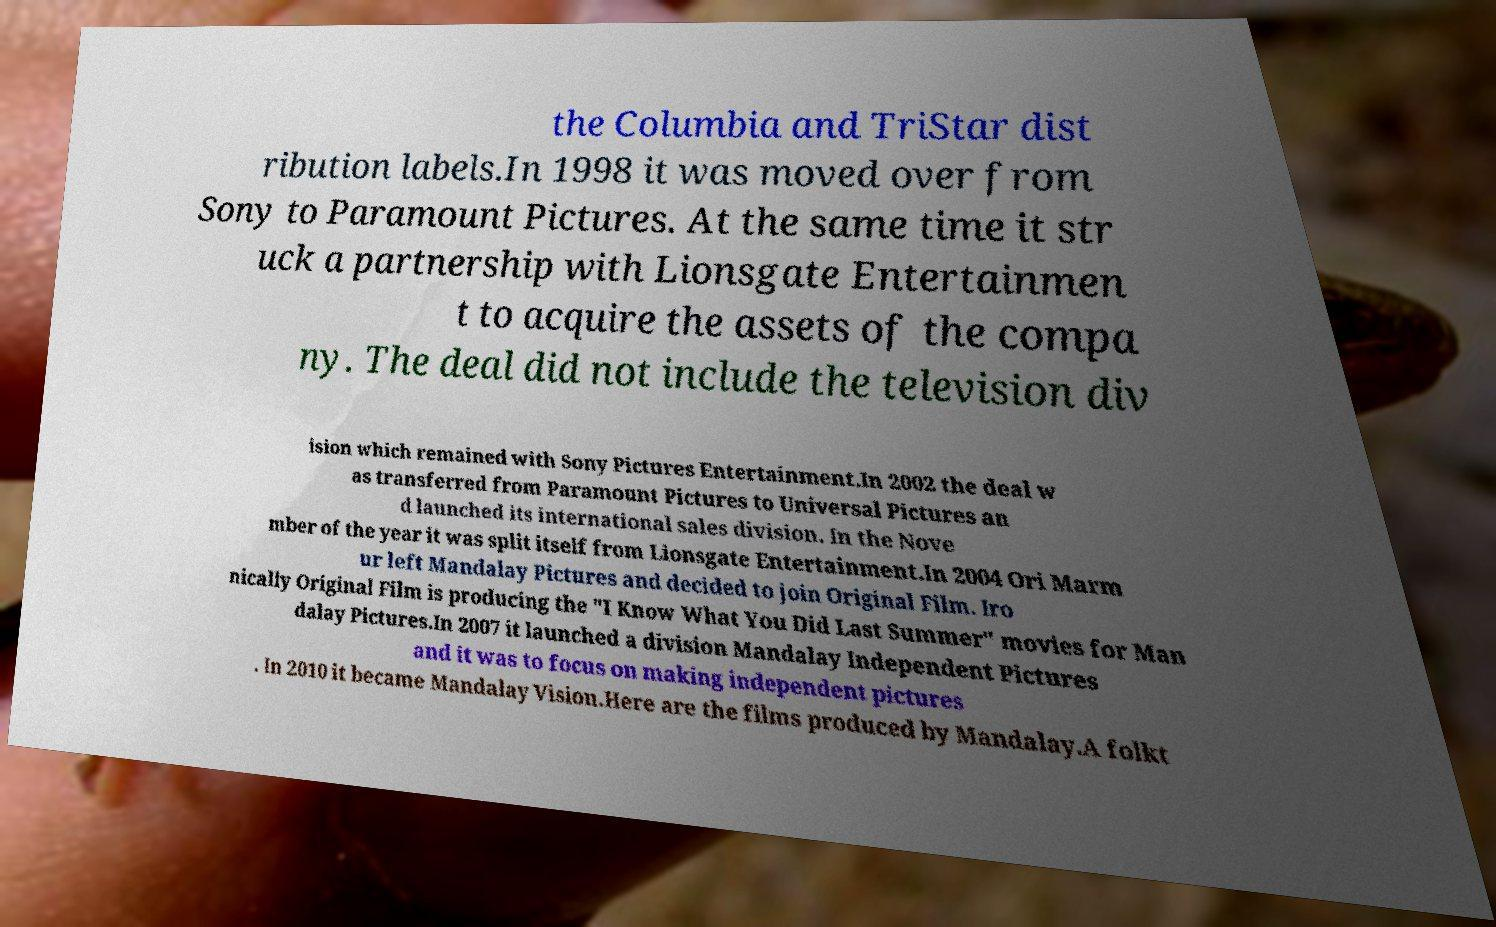What messages or text are displayed in this image? I need them in a readable, typed format. the Columbia and TriStar dist ribution labels.In 1998 it was moved over from Sony to Paramount Pictures. At the same time it str uck a partnership with Lionsgate Entertainmen t to acquire the assets of the compa ny. The deal did not include the television div ision which remained with Sony Pictures Entertainment.In 2002 the deal w as transferred from Paramount Pictures to Universal Pictures an d launched its international sales division. In the Nove mber of the year it was split itself from Lionsgate Entertainment.In 2004 Ori Marm ur left Mandalay Pictures and decided to join Original Film. Iro nically Original Film is producing the "I Know What You Did Last Summer" movies for Man dalay Pictures.In 2007 it launched a division Mandalay Independent Pictures and it was to focus on making independent pictures . In 2010 it became Mandalay Vision.Here are the films produced by Mandalay.A folkt 